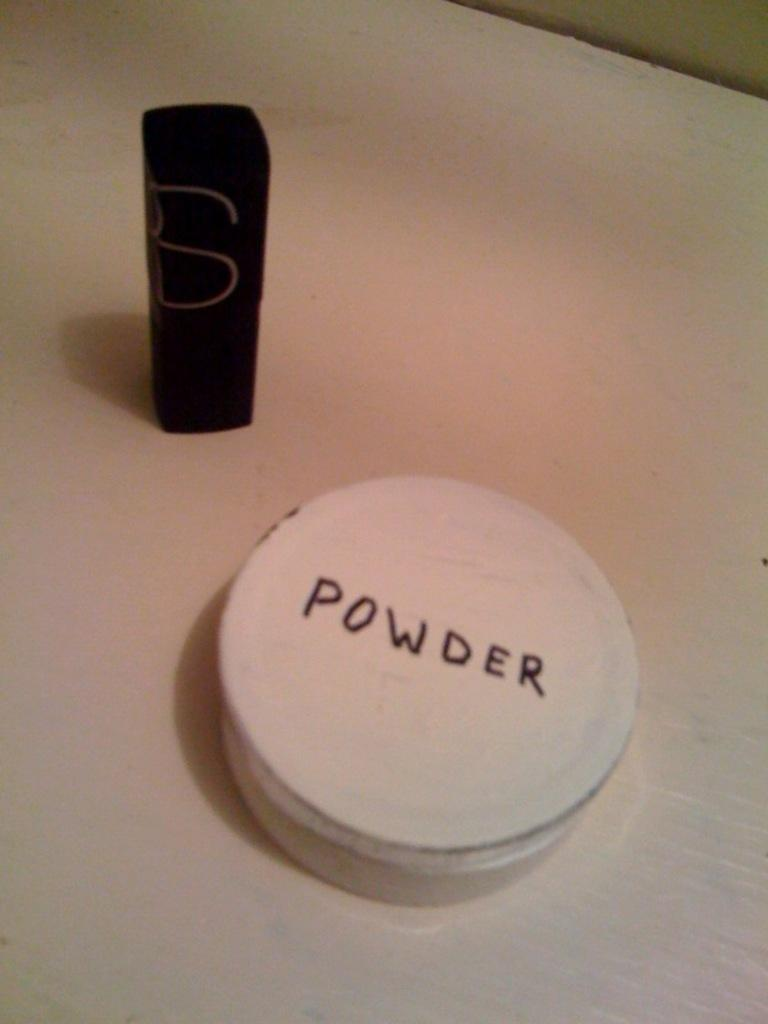<image>
Present a compact description of the photo's key features. A small jar of powder is labeled with hand printed capital letters. 